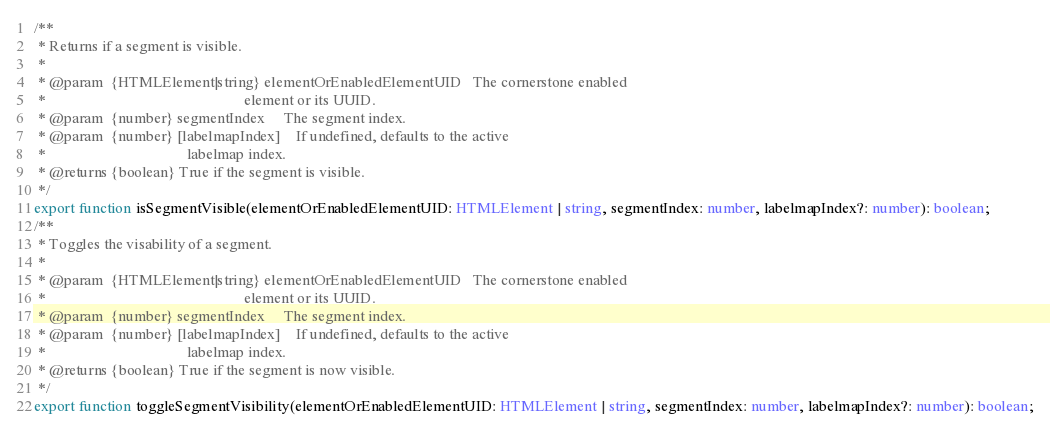<code> <loc_0><loc_0><loc_500><loc_500><_TypeScript_>/**
 * Returns if a segment is visible.
 *
 * @param  {HTMLElement|string} elementOrEnabledElementUID   The cornerstone enabled
 *                                                    element or its UUID.
 * @param  {number} segmentIndex     The segment index.
 * @param  {number} [labelmapIndex]    If undefined, defaults to the active
 *                                     labelmap index.
 * @returns {boolean} True if the segment is visible.
 */
export function isSegmentVisible(elementOrEnabledElementUID: HTMLElement | string, segmentIndex: number, labelmapIndex?: number): boolean;
/**
 * Toggles the visability of a segment.
 *
 * @param  {HTMLElement|string} elementOrEnabledElementUID   The cornerstone enabled
 *                                                    element or its UUID.
 * @param  {number} segmentIndex     The segment index.
 * @param  {number} [labelmapIndex]    If undefined, defaults to the active
 *                                     labelmap index.
 * @returns {boolean} True if the segment is now visible.
 */
export function toggleSegmentVisibility(elementOrEnabledElementUID: HTMLElement | string, segmentIndex: number, labelmapIndex?: number): boolean;
</code> 